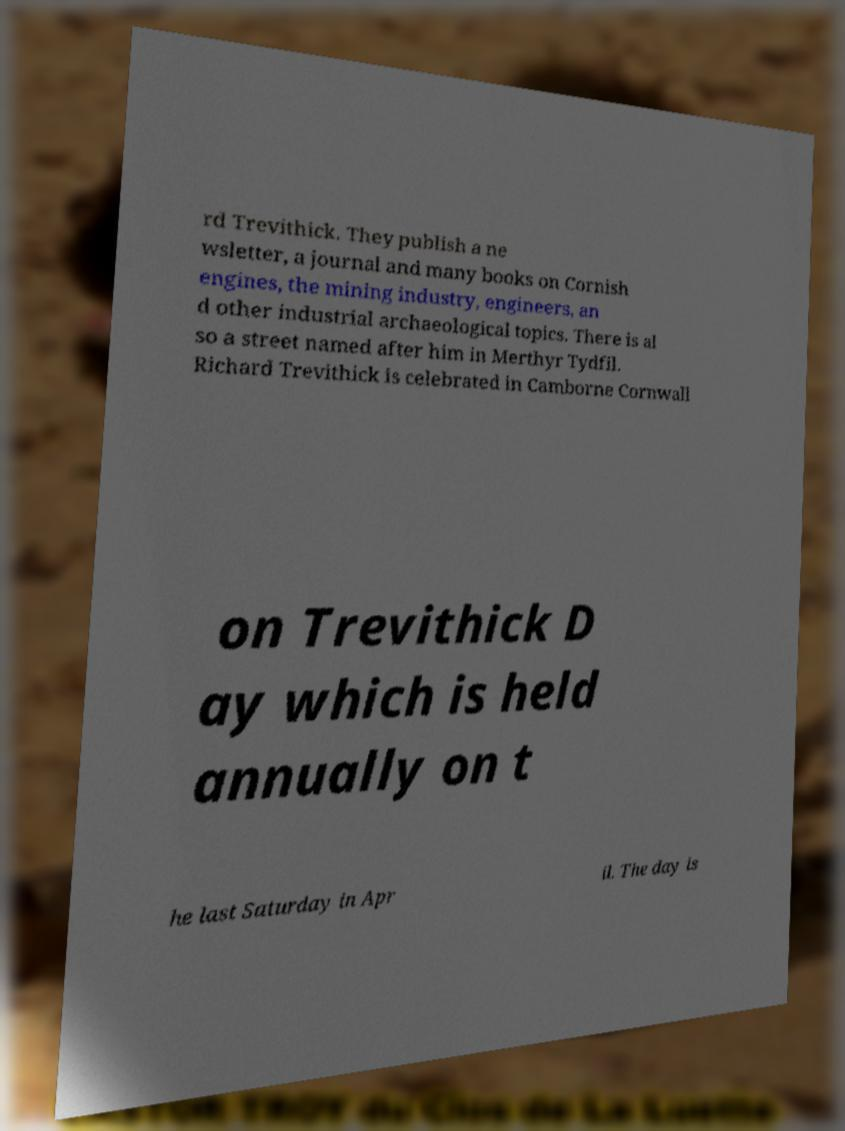Can you read and provide the text displayed in the image?This photo seems to have some interesting text. Can you extract and type it out for me? rd Trevithick. They publish a ne wsletter, a journal and many books on Cornish engines, the mining industry, engineers, an d other industrial archaeological topics. There is al so a street named after him in Merthyr Tydfil. Richard Trevithick is celebrated in Camborne Cornwall on Trevithick D ay which is held annually on t he last Saturday in Apr il. The day is 